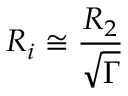<formula> <loc_0><loc_0><loc_500><loc_500>R _ { i } \cong \frac { R _ { 2 } } { \sqrt { \Gamma } }</formula> 